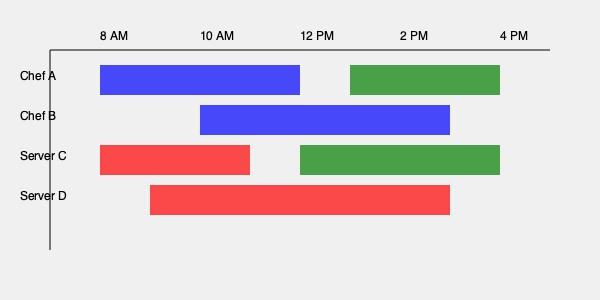Given the Gantt chart showing staff shifts for a restaurant, what is the minimum number of staff members needed to ensure at least one chef and one server are present at all times between 8 AM and 4 PM? To solve this problem, we need to analyze the Gantt chart and follow these steps:

1. Identify the time slots:
   - 8 AM - 10 AM
   - 10 AM - 12 PM
   - 12 PM - 2 PM
   - 2 PM - 4 PM

2. Analyze chef coverage:
   - Chef A: 8 AM - 12 PM, 2 PM - 4 PM
   - Chef B: 10 AM - 2 PM

3. Analyze server coverage:
   - Server C: 8 AM - 11 AM, 1 PM - 4 PM
   - Server D: 9 AM - 3 PM

4. Check each time slot for minimum coverage:
   - 8 AM - 9 AM: Chef A and Server C (2 staff)
   - 9 AM - 10 AM: Chef A, Server C, and Server D (3 staff)
   - 10 AM - 11 AM: Chef A, Chef B, Server C, and Server D (4 staff)
   - 11 AM - 12 PM: Chef A, Chef B, and Server D (3 staff)
   - 12 PM - 1 PM: Chef B and Server D (2 staff)
   - 1 PM - 2 PM: Chef B, Server C, and Server D (3 staff)
   - 2 PM - 3 PM: Chef A, Server C, and Server D (3 staff)
   - 3 PM - 4 PM: Chef A and Server C (2 staff)

5. Determine the minimum number of staff:
   The minimum number of staff needed is the maximum number of staff present in any time slot, which is 4 (occurring from 10 AM to 11 AM).

This staffing arrangement ensures that there is always at least one chef and one server present throughout the entire period from 8 AM to 4 PM.
Answer: 4 staff members 